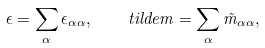Convert formula to latex. <formula><loc_0><loc_0><loc_500><loc_500>\epsilon = \sum _ { \alpha } \epsilon _ { \alpha \alpha } , \quad t i l d e { m } = \sum _ { \alpha } \tilde { m } _ { \alpha \alpha } ,</formula> 